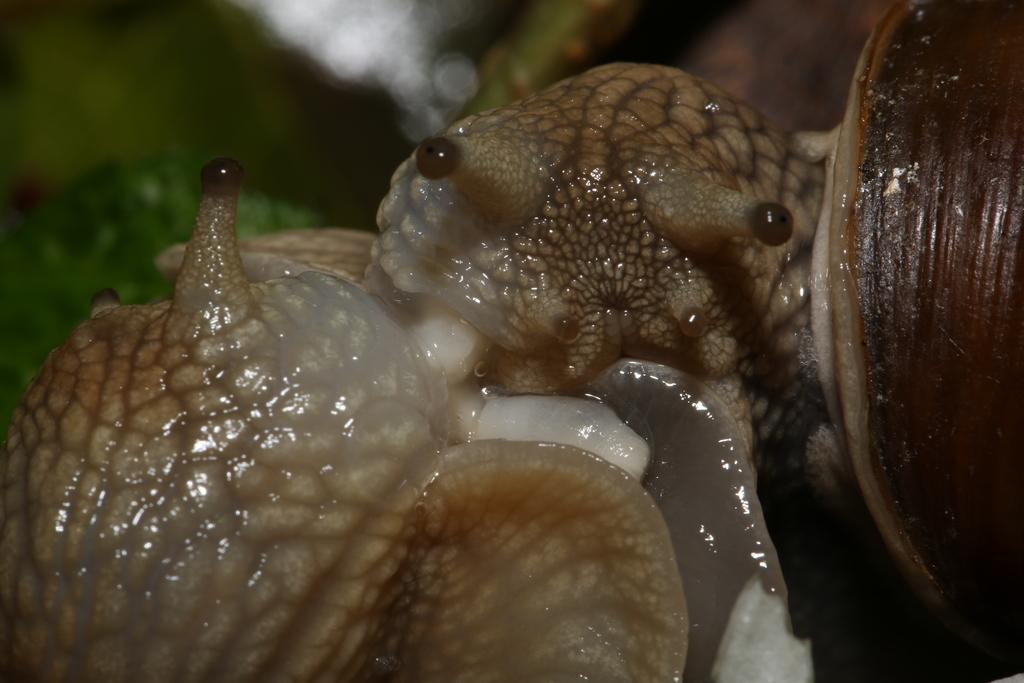What type of animals are in the image? There are snails in the image. Can you describe the background of the image? The background of the image is blurred. What type of yard is visible in the image? There is no yard visible in the image; it only features snails and a blurred background. What type of trade is being conducted in the image? There is no trade being conducted in the image; it only features snails and a blurred background. 